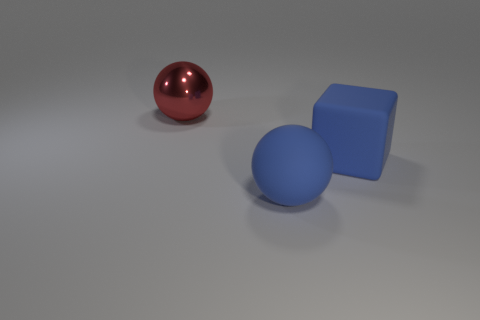Can you describe the lighting condition in the scene? The lighting in this scene is diffuse, with soft shadows indicating an overhead and ambient light source. This even, nondirectional light minimizes harsh shadows, suggesting an interior environment with well-distributed artificial lighting. 